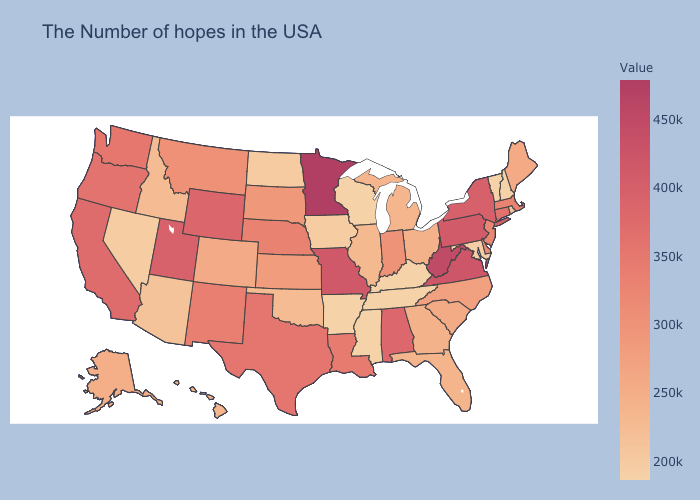Which states have the highest value in the USA?
Be succinct. Minnesota. Which states have the highest value in the USA?
Keep it brief. Minnesota. Does Missouri have the highest value in the USA?
Concise answer only. No. Among the states that border Montana , which have the highest value?
Write a very short answer. Wyoming. Does New Hampshire have the lowest value in the USA?
Concise answer only. Yes. Does Wisconsin have the lowest value in the USA?
Give a very brief answer. Yes. 